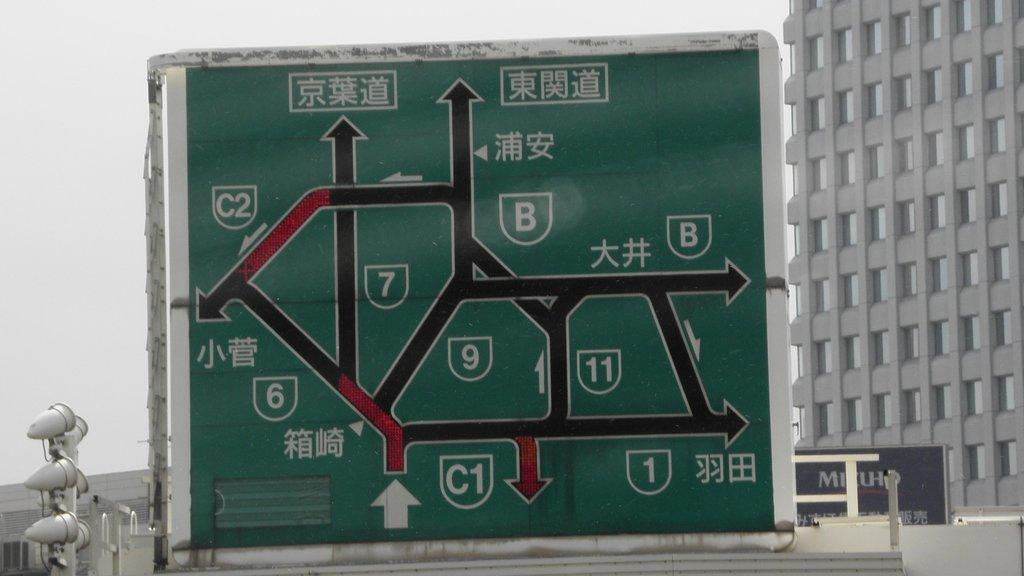Provide a one-sentence caption for the provided image. A green colored roadway map with Asian writing on it as well as English numbers and letters. 